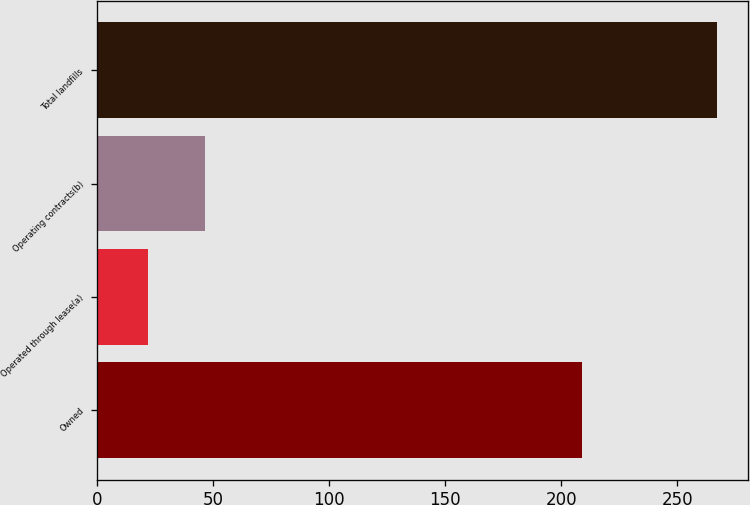<chart> <loc_0><loc_0><loc_500><loc_500><bar_chart><fcel>Owned<fcel>Operated through lease(a)<fcel>Operating contracts(b)<fcel>Total landfills<nl><fcel>209<fcel>22<fcel>46.5<fcel>267<nl></chart> 